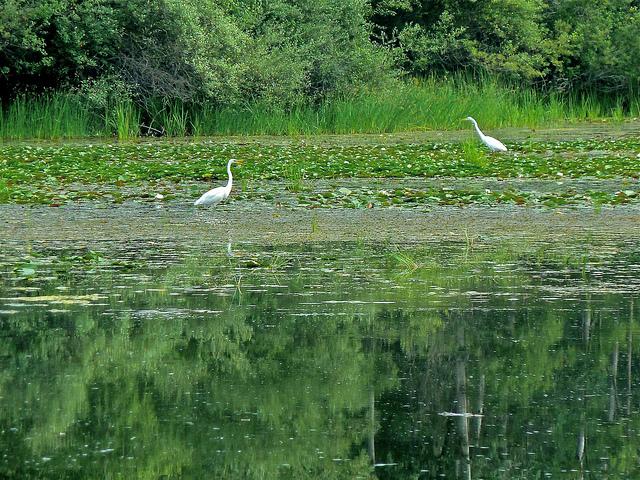Can this bird swim?
Concise answer only. Yes. Are these pelicans?
Give a very brief answer. No. Are the birds facing away from each other?
Short answer required. No. Are there reflections in the water?
Give a very brief answer. Yes. 